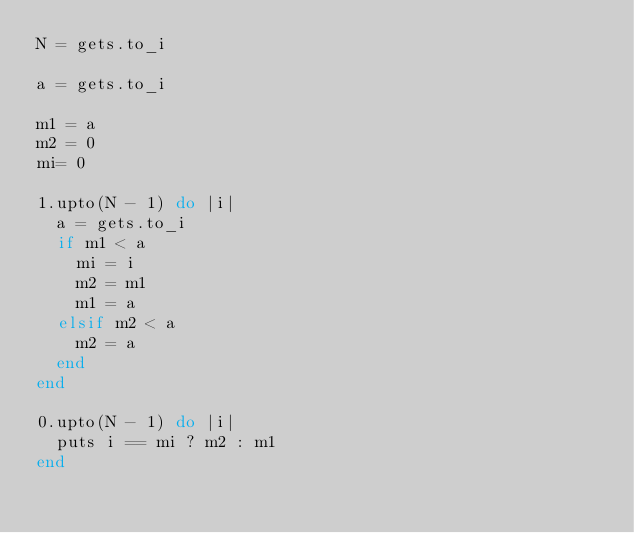Convert code to text. <code><loc_0><loc_0><loc_500><loc_500><_Ruby_>N = gets.to_i

a = gets.to_i

m1 = a
m2 = 0
mi= 0

1.upto(N - 1) do |i|
  a = gets.to_i
  if m1 < a
    mi = i
    m2 = m1
    m1 = a
  elsif m2 < a
    m2 = a
  end 
end

0.upto(N - 1) do |i|
  puts i == mi ? m2 : m1
end
</code> 